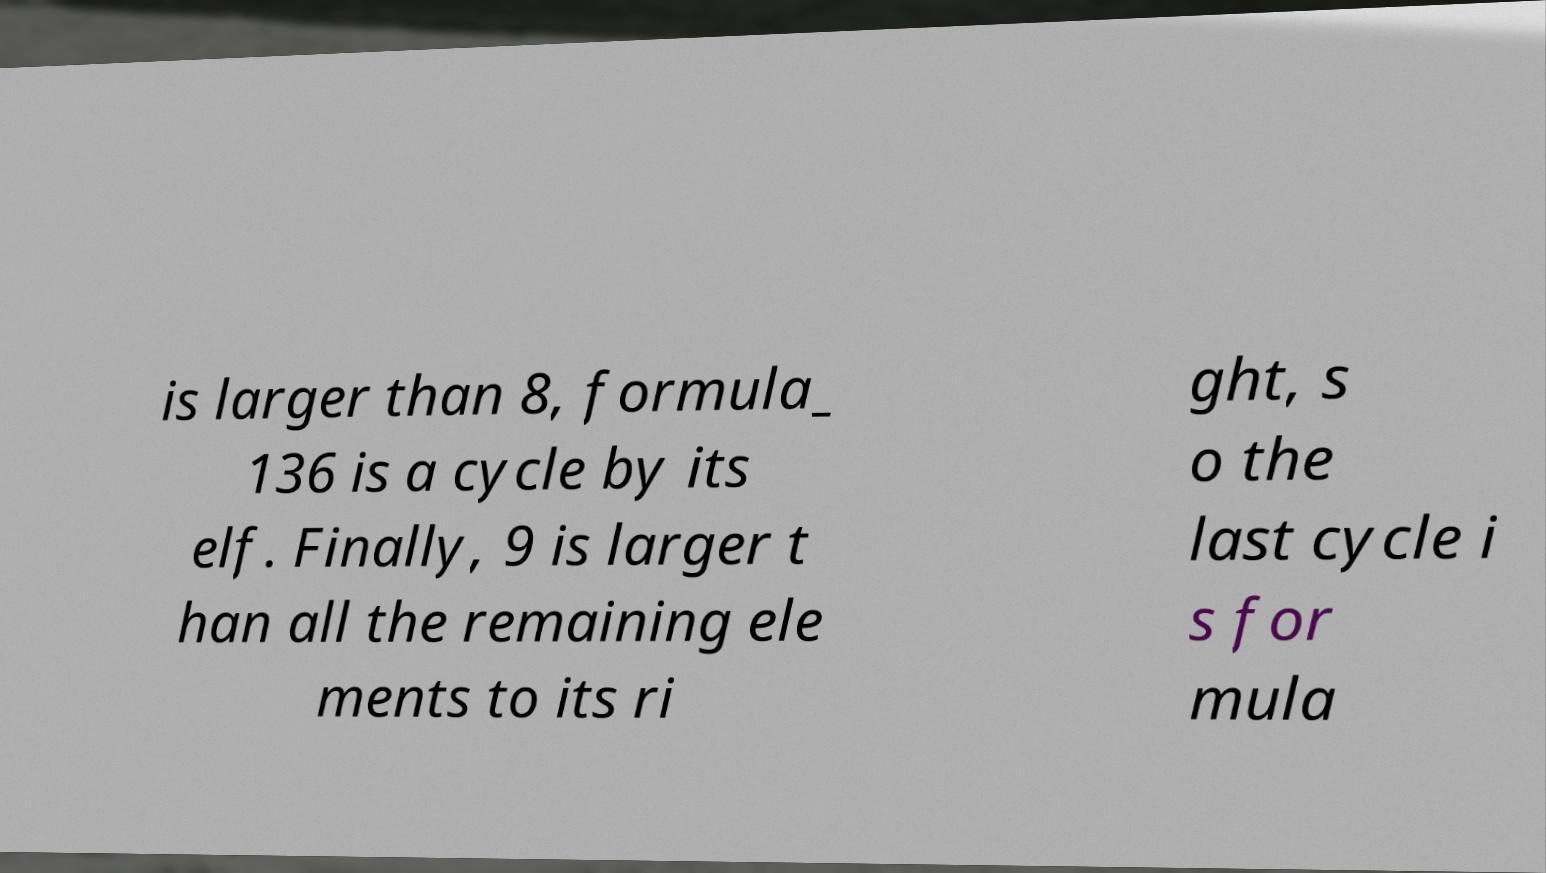Can you read and provide the text displayed in the image?This photo seems to have some interesting text. Can you extract and type it out for me? is larger than 8, formula_ 136 is a cycle by its elf. Finally, 9 is larger t han all the remaining ele ments to its ri ght, s o the last cycle i s for mula 